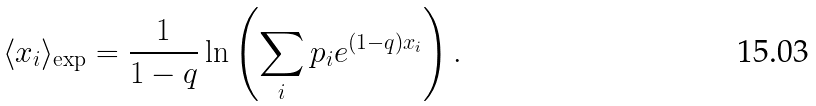<formula> <loc_0><loc_0><loc_500><loc_500>\langle x _ { i } \rangle _ { \exp } = \frac { 1 } { 1 - q } \ln \left ( \sum _ { i } p _ { i } e ^ { ( 1 - q ) x _ { i } } \right ) .</formula> 